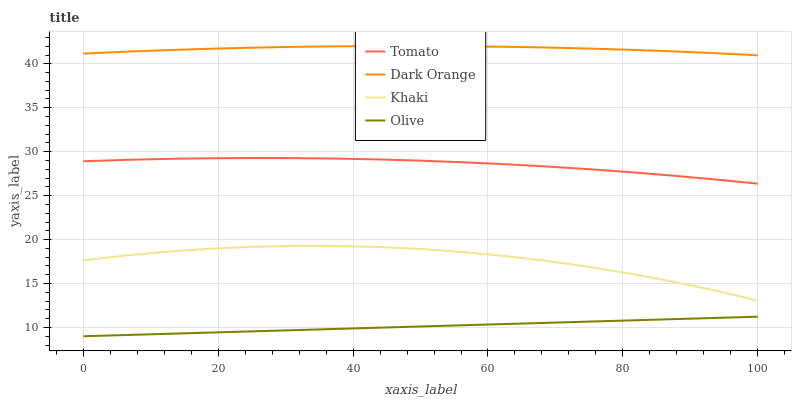Does Olive have the minimum area under the curve?
Answer yes or no. Yes. Does Dark Orange have the maximum area under the curve?
Answer yes or no. Yes. Does Khaki have the minimum area under the curve?
Answer yes or no. No. Does Khaki have the maximum area under the curve?
Answer yes or no. No. Is Olive the smoothest?
Answer yes or no. Yes. Is Khaki the roughest?
Answer yes or no. Yes. Is Dark Orange the smoothest?
Answer yes or no. No. Is Dark Orange the roughest?
Answer yes or no. No. Does Olive have the lowest value?
Answer yes or no. Yes. Does Khaki have the lowest value?
Answer yes or no. No. Does Dark Orange have the highest value?
Answer yes or no. Yes. Does Khaki have the highest value?
Answer yes or no. No. Is Olive less than Khaki?
Answer yes or no. Yes. Is Dark Orange greater than Tomato?
Answer yes or no. Yes. Does Olive intersect Khaki?
Answer yes or no. No. 